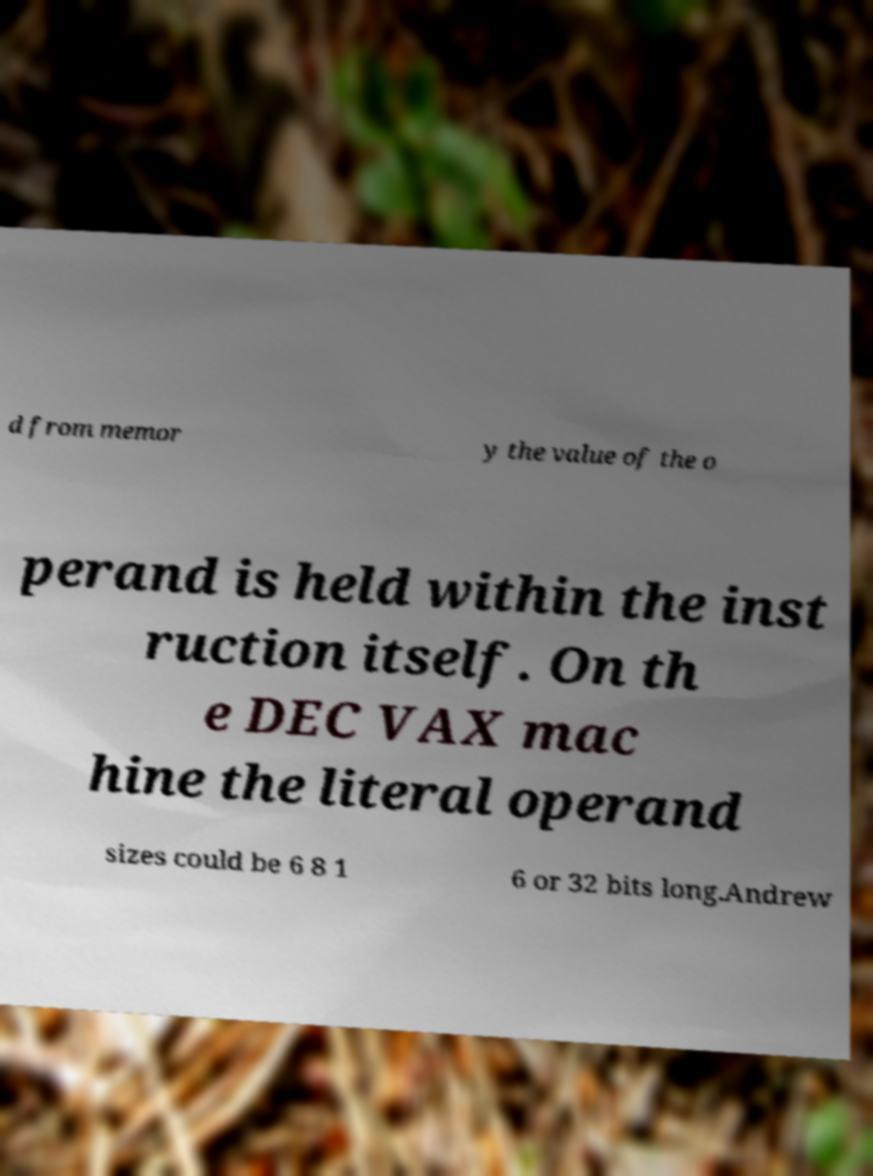Can you accurately transcribe the text from the provided image for me? d from memor y the value of the o perand is held within the inst ruction itself. On th e DEC VAX mac hine the literal operand sizes could be 6 8 1 6 or 32 bits long.Andrew 